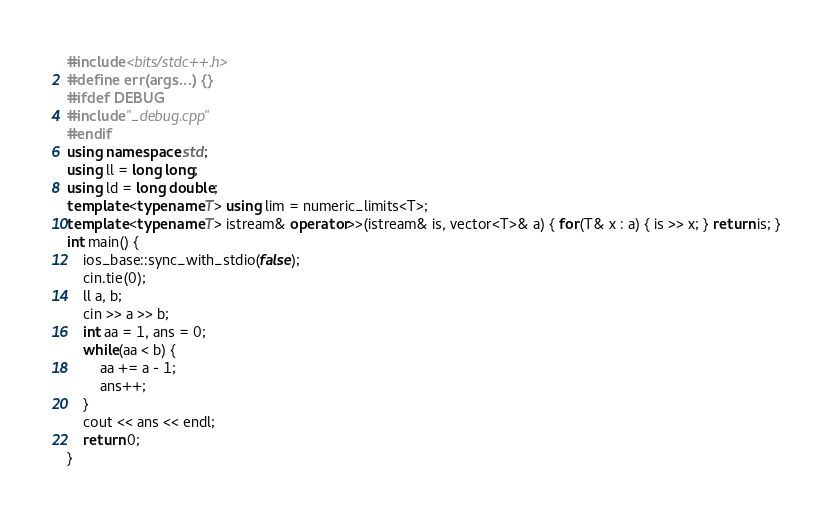<code> <loc_0><loc_0><loc_500><loc_500><_C++_>#include <bits/stdc++.h>
#define err(args...) {}
#ifdef DEBUG
#include "_debug.cpp"
#endif
using namespace std;
using ll = long long;
using ld = long double;
template <typename T> using lim = numeric_limits<T>;
template <typename T> istream& operator>>(istream& is, vector<T>& a) { for(T& x : a) { is >> x; } return is; }
int main() {
    ios_base::sync_with_stdio(false);
    cin.tie(0);
    ll a, b;
    cin >> a >> b;
    int aa = 1, ans = 0;
    while(aa < b) {
        aa += a - 1;
        ans++;
    }
    cout << ans << endl;
    return 0;
}
</code> 